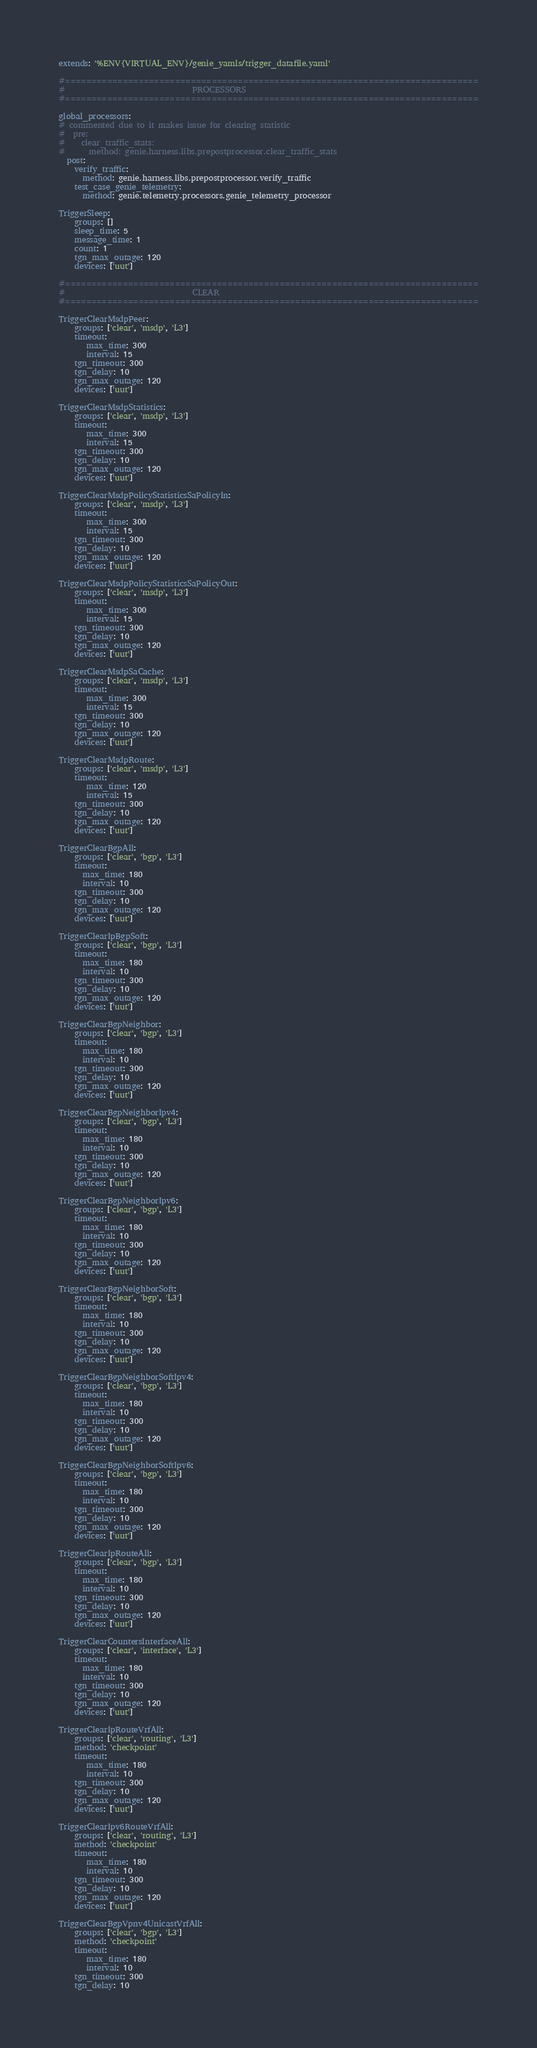Convert code to text. <code><loc_0><loc_0><loc_500><loc_500><_YAML_>extends: '%ENV{VIRTUAL_ENV}/genie_yamls/trigger_datafile.yaml'

#===============================================================================
#                                PROCESSORS
#===============================================================================

global_processors:
# commented due to it makes issue for clearing statistic
#  pre:
#    clear_traffic_stats:
#      method: genie.harness.libs.prepostprocessor.clear_traffic_stats
  post:
    verify_traffic:
      method: genie.harness.libs.prepostprocessor.verify_traffic
    test_case_genie_telemetry:
      method: genie.telemetry.processors.genie_telemetry_processor

TriggerSleep:
    groups: []
    sleep_time: 5
    message_time: 1
    count: 1
    tgn_max_outage: 120
    devices: ['uut']

#===============================================================================
#                                CLEAR
#===============================================================================

TriggerClearMsdpPeer:
    groups: ['clear', 'msdp', 'L3']
    timeout:
       max_time: 300
       interval: 15
    tgn_timeout: 300
    tgn_delay: 10
    tgn_max_outage: 120
    devices: ['uut']

TriggerClearMsdpStatistics:
    groups: ['clear', 'msdp', 'L3']
    timeout:
       max_time: 300
       interval: 15
    tgn_timeout: 300
    tgn_delay: 10
    tgn_max_outage: 120
    devices: ['uut']

TriggerClearMsdpPolicyStatisticsSaPolicyIn:
    groups: ['clear', 'msdp', 'L3']
    timeout:
       max_time: 300
       interval: 15
    tgn_timeout: 300
    tgn_delay: 10
    tgn_max_outage: 120
    devices: ['uut']

TriggerClearMsdpPolicyStatisticsSaPolicyOut:
    groups: ['clear', 'msdp', 'L3']
    timeout:
       max_time: 300
       interval: 15
    tgn_timeout: 300
    tgn_delay: 10
    tgn_max_outage: 120
    devices: ['uut']

TriggerClearMsdpSaCache:
    groups: ['clear', 'msdp', 'L3']
    timeout:
       max_time: 300
       interval: 15
    tgn_timeout: 300
    tgn_delay: 10
    tgn_max_outage: 120
    devices: ['uut']

TriggerClearMsdpRoute:
    groups: ['clear', 'msdp', 'L3']
    timeout:
       max_time: 120
       interval: 15
    tgn_timeout: 300
    tgn_delay: 10
    tgn_max_outage: 120
    devices: ['uut']

TriggerClearBgpAll:
    groups: ['clear', 'bgp', 'L3']
    timeout:
      max_time: 180
      interval: 10
    tgn_timeout: 300
    tgn_delay: 10
    tgn_max_outage: 120
    devices: ['uut']

TriggerClearIpBgpSoft:
    groups: ['clear', 'bgp', 'L3']
    timeout:
      max_time: 180
      interval: 10
    tgn_timeout: 300
    tgn_delay: 10
    tgn_max_outage: 120
    devices: ['uut']

TriggerClearBgpNeighbor:
    groups: ['clear', 'bgp', 'L3']
    timeout:
      max_time: 180
      interval: 10
    tgn_timeout: 300
    tgn_delay: 10
    tgn_max_outage: 120
    devices: ['uut']

TriggerClearBgpNeighborIpv4:
    groups: ['clear', 'bgp', 'L3']
    timeout:
      max_time: 180
      interval: 10
    tgn_timeout: 300
    tgn_delay: 10
    tgn_max_outage: 120
    devices: ['uut']

TriggerClearBgpNeighborIpv6:
    groups: ['clear', 'bgp', 'L3']
    timeout:
      max_time: 180
      interval: 10
    tgn_timeout: 300
    tgn_delay: 10
    tgn_max_outage: 120
    devices: ['uut']

TriggerClearBgpNeighborSoft:
    groups: ['clear', 'bgp', 'L3']
    timeout:
      max_time: 180
      interval: 10
    tgn_timeout: 300
    tgn_delay: 10
    tgn_max_outage: 120
    devices: ['uut']

TriggerClearBgpNeighborSoftIpv4:
    groups: ['clear', 'bgp', 'L3']
    timeout:
      max_time: 180
      interval: 10
    tgn_timeout: 300
    tgn_delay: 10
    tgn_max_outage: 120
    devices: ['uut']

TriggerClearBgpNeighborSoftIpv6:
    groups: ['clear', 'bgp', 'L3']
    timeout:
      max_time: 180
      interval: 10
    tgn_timeout: 300
    tgn_delay: 10
    tgn_max_outage: 120
    devices: ['uut']

TriggerClearIpRouteAll:
    groups: ['clear', 'bgp', 'L3']
    timeout:
      max_time: 180
      interval: 10
    tgn_timeout: 300
    tgn_delay: 10
    tgn_max_outage: 120
    devices: ['uut']

TriggerClearCountersInterfaceAll:
    groups: ['clear', 'interface', 'L3']
    timeout:
      max_time: 180
      interval: 10
    tgn_timeout: 300
    tgn_delay: 10
    tgn_max_outage: 120
    devices: ['uut']

TriggerClearIpRouteVrfAll:
    groups: ['clear', 'routing', 'L3']
    method: 'checkpoint'
    timeout:
       max_time: 180
       interval: 10
    tgn_timeout: 300
    tgn_delay: 10
    tgn_max_outage: 120
    devices: ['uut']

TriggerClearIpv6RouteVrfAll:
    groups: ['clear', 'routing', 'L3']
    method: 'checkpoint'
    timeout:
       max_time: 180
       interval: 10
    tgn_timeout: 300
    tgn_delay: 10
    tgn_max_outage: 120
    devices: ['uut']

TriggerClearBgpVpnv4UnicastVrfAll:
    groups: ['clear', 'bgp', 'L3']
    method: 'checkpoint'
    timeout:
       max_time: 180
       interval: 10
    tgn_timeout: 300
    tgn_delay: 10</code> 